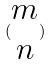Convert formula to latex. <formula><loc_0><loc_0><loc_500><loc_500>( \begin{matrix} m \\ n \end{matrix} )</formula> 